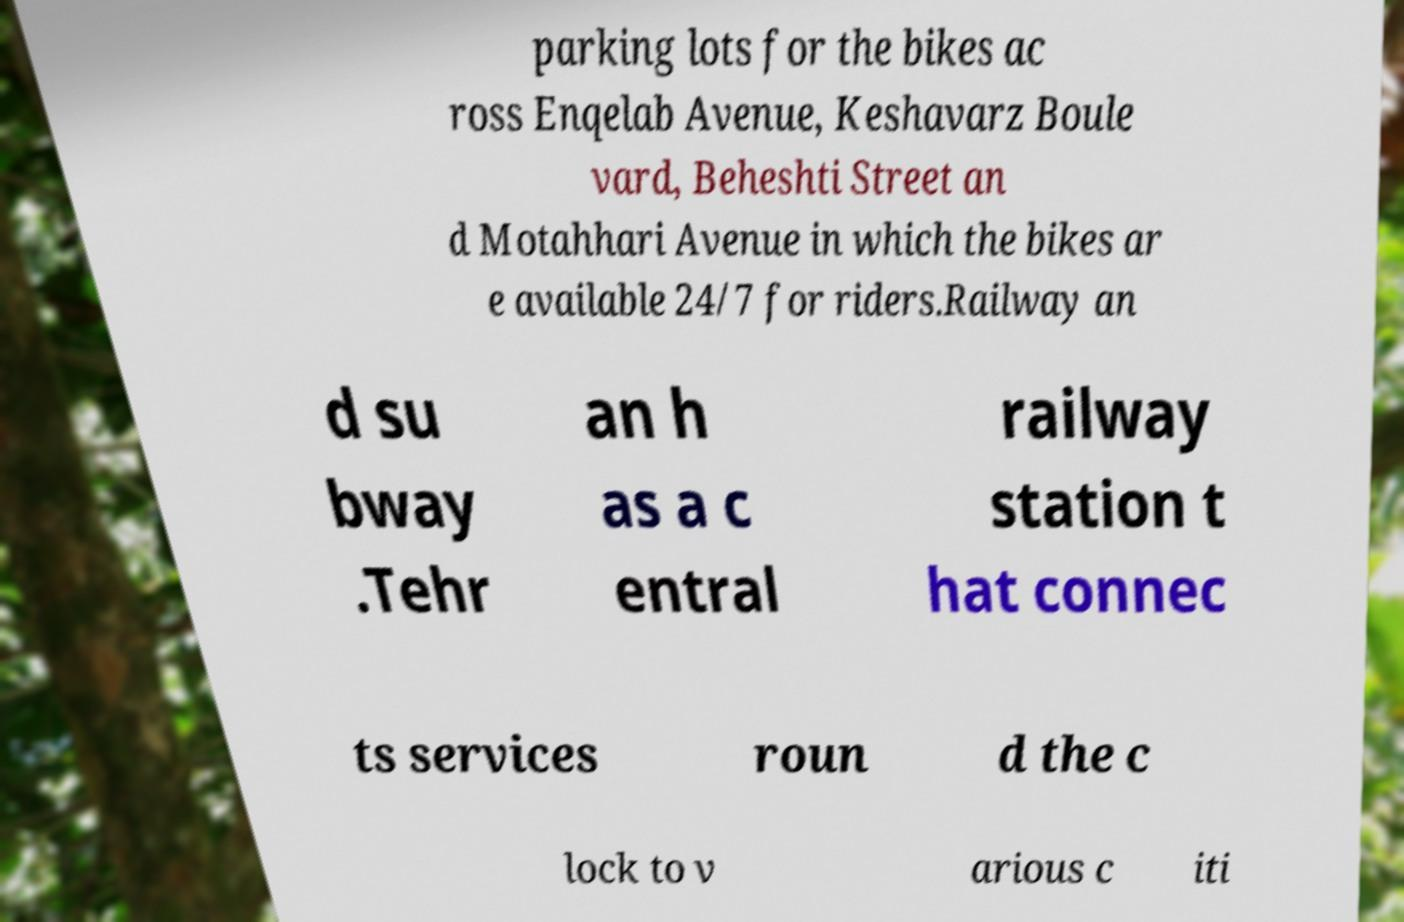I need the written content from this picture converted into text. Can you do that? parking lots for the bikes ac ross Enqelab Avenue, Keshavarz Boule vard, Beheshti Street an d Motahhari Avenue in which the bikes ar e available 24/7 for riders.Railway an d su bway .Tehr an h as a c entral railway station t hat connec ts services roun d the c lock to v arious c iti 